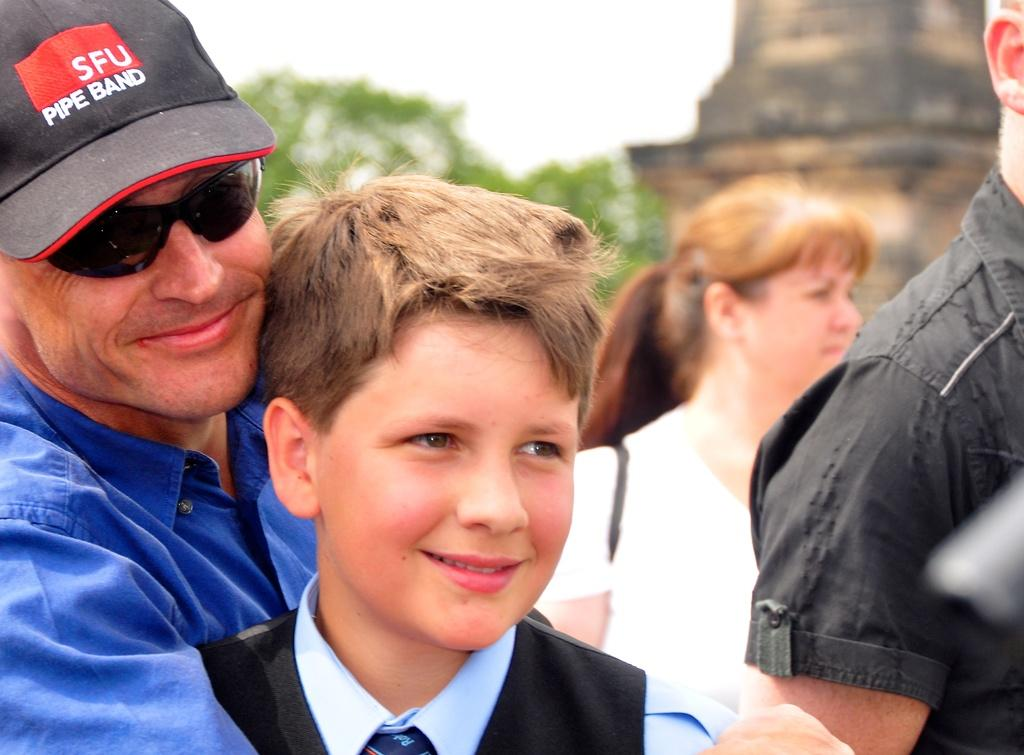How many people are in the image? There are a few people in the image. What can be seen in the background of the image? There are trees and an unspecified object in the background of the image. What is visible in the sky in the image? The sky is visible in the image. What type of potato is being used as a zephyr in the image? There is no potato or zephyr present in the image. Where is the desk located in the image? There is no desk present in the image. 